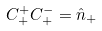Convert formula to latex. <formula><loc_0><loc_0><loc_500><loc_500>C _ { + } ^ { + } C _ { + } ^ { - } = \hat { n } _ { + }</formula> 